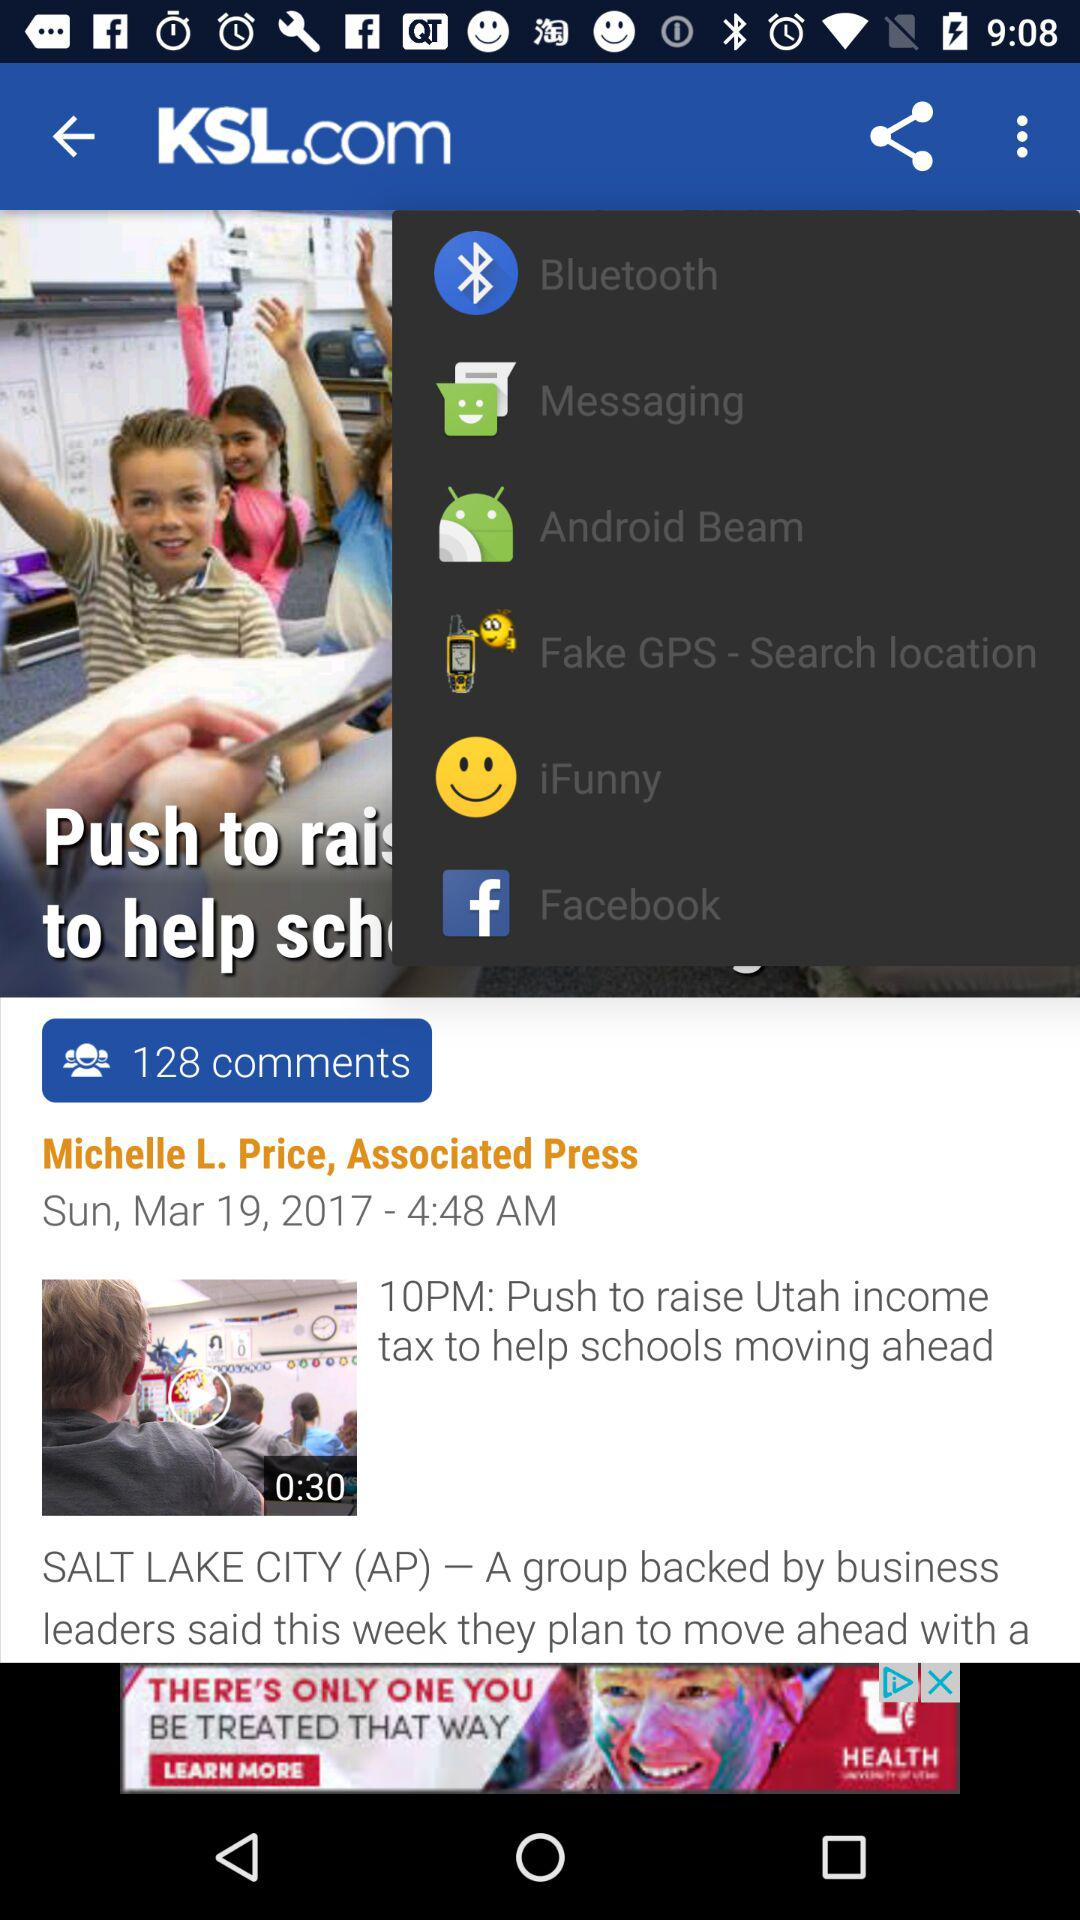How many seconds long is the video?
Answer the question using a single word or phrase. 0:30 